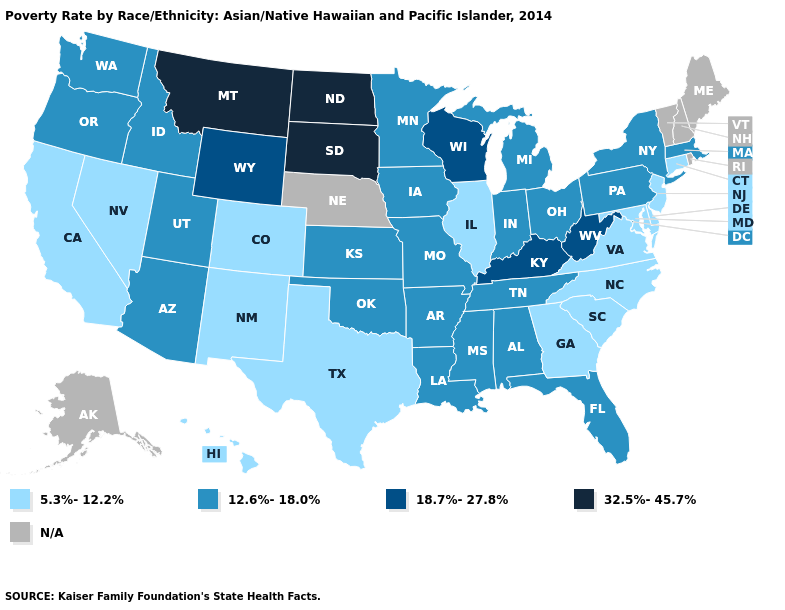Does the map have missing data?
Be succinct. Yes. What is the value of Louisiana?
Be succinct. 12.6%-18.0%. How many symbols are there in the legend?
Short answer required. 5. Does Montana have the highest value in the West?
Short answer required. Yes. Which states hav the highest value in the West?
Answer briefly. Montana. What is the highest value in states that border Delaware?
Give a very brief answer. 12.6%-18.0%. Which states hav the highest value in the West?
Give a very brief answer. Montana. Name the states that have a value in the range 5.3%-12.2%?
Give a very brief answer. California, Colorado, Connecticut, Delaware, Georgia, Hawaii, Illinois, Maryland, Nevada, New Jersey, New Mexico, North Carolina, South Carolina, Texas, Virginia. What is the value of New York?
Give a very brief answer. 12.6%-18.0%. What is the value of Connecticut?
Give a very brief answer. 5.3%-12.2%. Among the states that border North Carolina , does Tennessee have the highest value?
Quick response, please. Yes. Does the map have missing data?
Answer briefly. Yes. What is the value of Montana?
Give a very brief answer. 32.5%-45.7%. Does the first symbol in the legend represent the smallest category?
Short answer required. Yes. What is the value of Michigan?
Answer briefly. 12.6%-18.0%. 